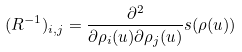Convert formula to latex. <formula><loc_0><loc_0><loc_500><loc_500>( R ^ { - 1 } ) _ { i , j } = \frac { \partial ^ { 2 } } { \partial \rho _ { i } ( u ) \partial \rho _ { j } ( u ) } s ( \rho ( u ) )</formula> 